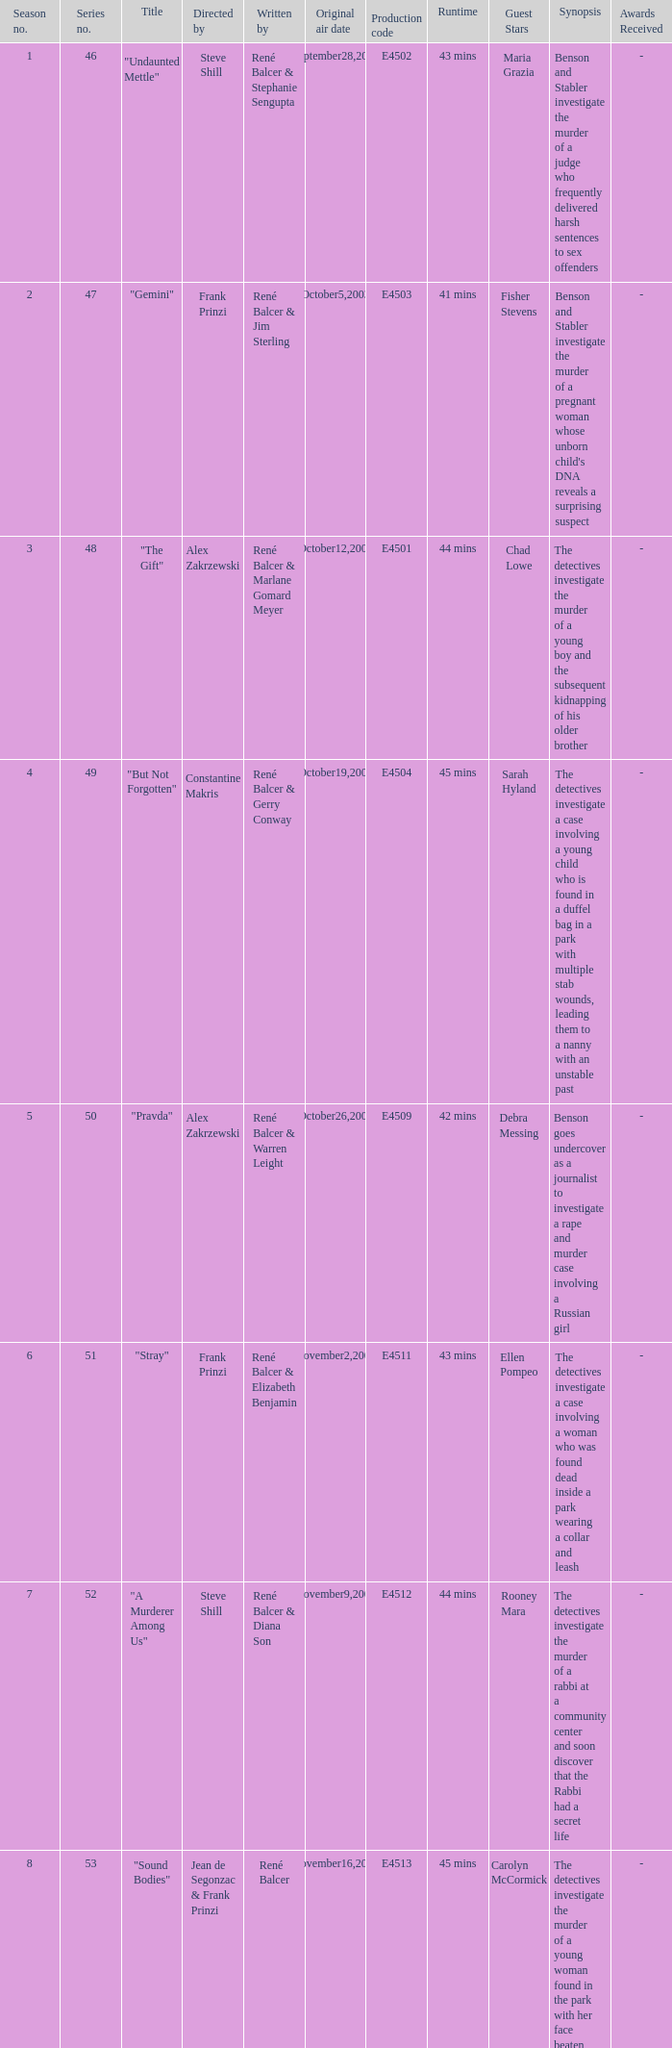Who wrote the episode with e4515 as the production code? René Balcer & Elizabeth Benjamin. 